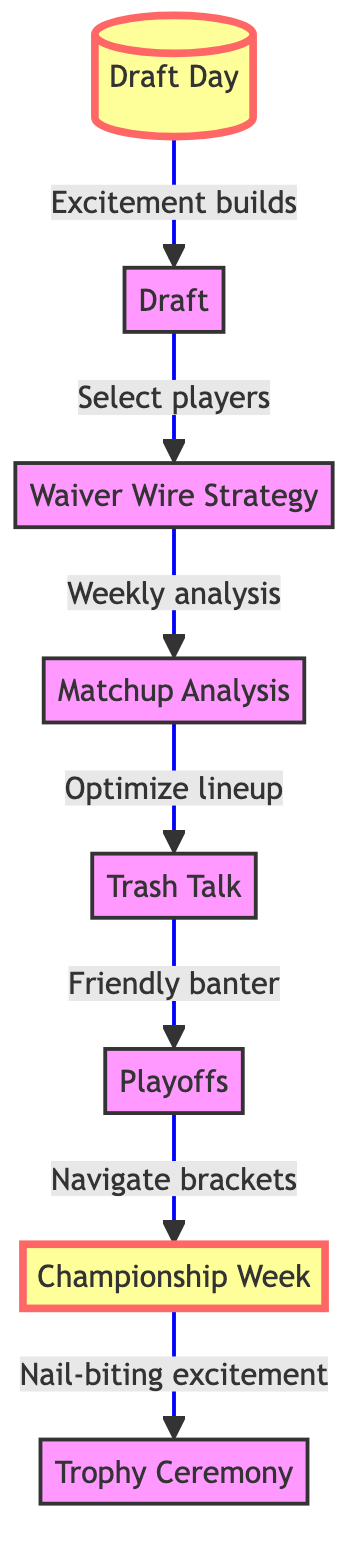What is the first node in the flowchart? The first node is labeled "Draft Day." This can be determined by following the arrows from the starting point of the diagram, which points to "Draft Day."
Answer: Draft Day What comes after the "Draft" node? The node that follows "Draft" is "Waiver Wire Strategy." This is visible as the arrow leading out of "Draft" points directly to "Waiver Wire Strategy."
Answer: Waiver Wire Strategy How many nodes are present in the flowchart? There are a total of eight nodes in the diagram: Draft Day, Draft, Waiver Wire Strategy, Matchup Analysis, Trash Talk, Playoffs, Championship Week, and Trophy Ceremony. Counting each node gives a total of eight.
Answer: 8 What type of interaction occurs after "Trash Talk"? After "Trash Talk," the interaction leads to "Playoffs." The arrow from "Trash Talk" clearly shows the flow towards the "Playoffs" node, indicating a progression in the journey.
Answer: Playoffs Which node is highlighted in the diagram? The nodes highlighted in the diagram are "Draft Day" and "Championship Week." The visual properties defined for these nodes include a bolder font style and larger font size, differentiating them from others.
Answer: Draft Day, Championship Week What action occurs before analyzing matchups? Before analyzing matchups, the action that takes place is "Waiver Wire Strategy." The flow chart shows that analyzing matchups comes after picking up players from the waiver wire, establishing a prerequisite action.
Answer: Waiver Wire Strategy What is the last step in the fan's journey? The last step in the journey is "Trophy Ceremony," which concludes the flow from "Championship Week." The end of that flow indicates the culmination of the fan's experience in the league.
Answer: Trophy Ceremony Which node involves player selection? The node that involves selecting players is "Draft." This is indicated explicitly by the description related to the action of participating in the draft where players are selected.
Answer: Draft What week encapsulates "nail-biting excitement"? "Championship Week" encapsulates "nail-biting excitement." The description directly associates this week with the heightened tension of competing for the championship.
Answer: Championship Week 